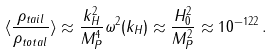Convert formula to latex. <formula><loc_0><loc_0><loc_500><loc_500>\langle \frac { \rho _ { t a i l } } { \rho _ { t o t a l } } \rangle \approx \frac { k _ { H } ^ { 2 } } { M _ { P } ^ { 4 } } \omega ^ { 2 } ( k _ { H } ) \approx \frac { H _ { 0 } ^ { 2 } } { M _ { P } ^ { 2 } } \approx 1 0 ^ { - 1 2 2 } \, .</formula> 